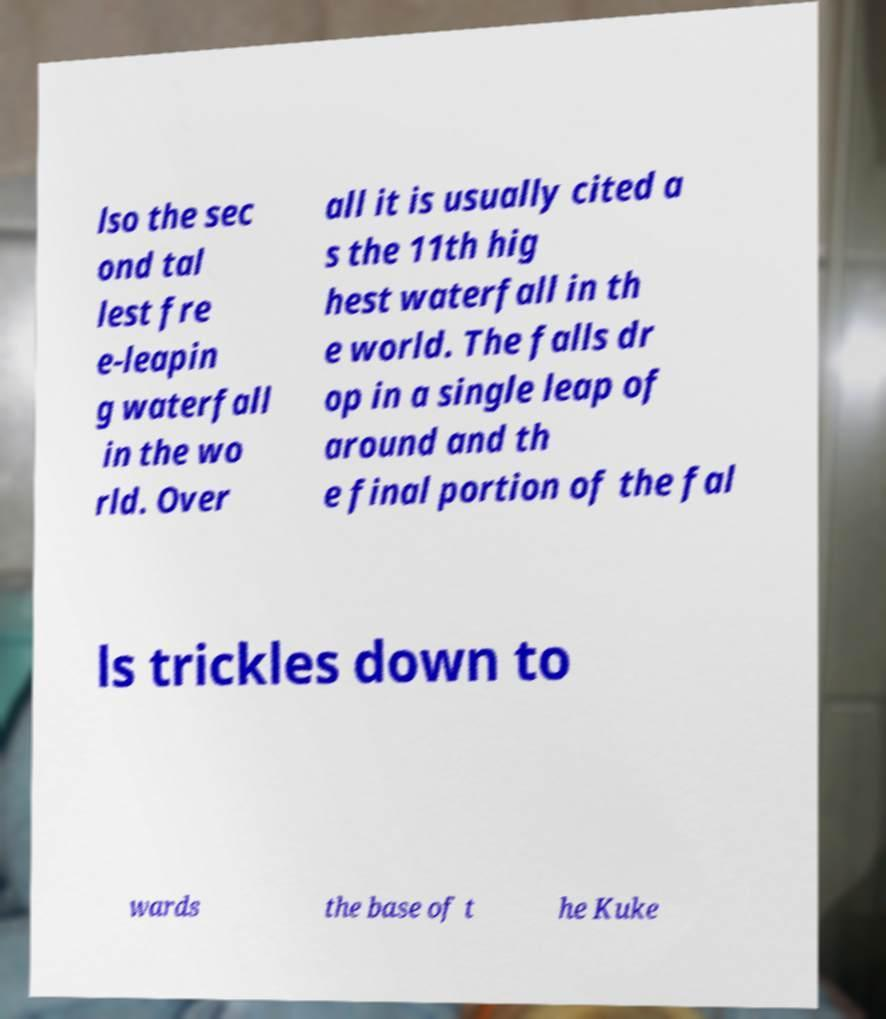What messages or text are displayed in this image? I need them in a readable, typed format. lso the sec ond tal lest fre e-leapin g waterfall in the wo rld. Over all it is usually cited a s the 11th hig hest waterfall in th e world. The falls dr op in a single leap of around and th e final portion of the fal ls trickles down to wards the base of t he Kuke 